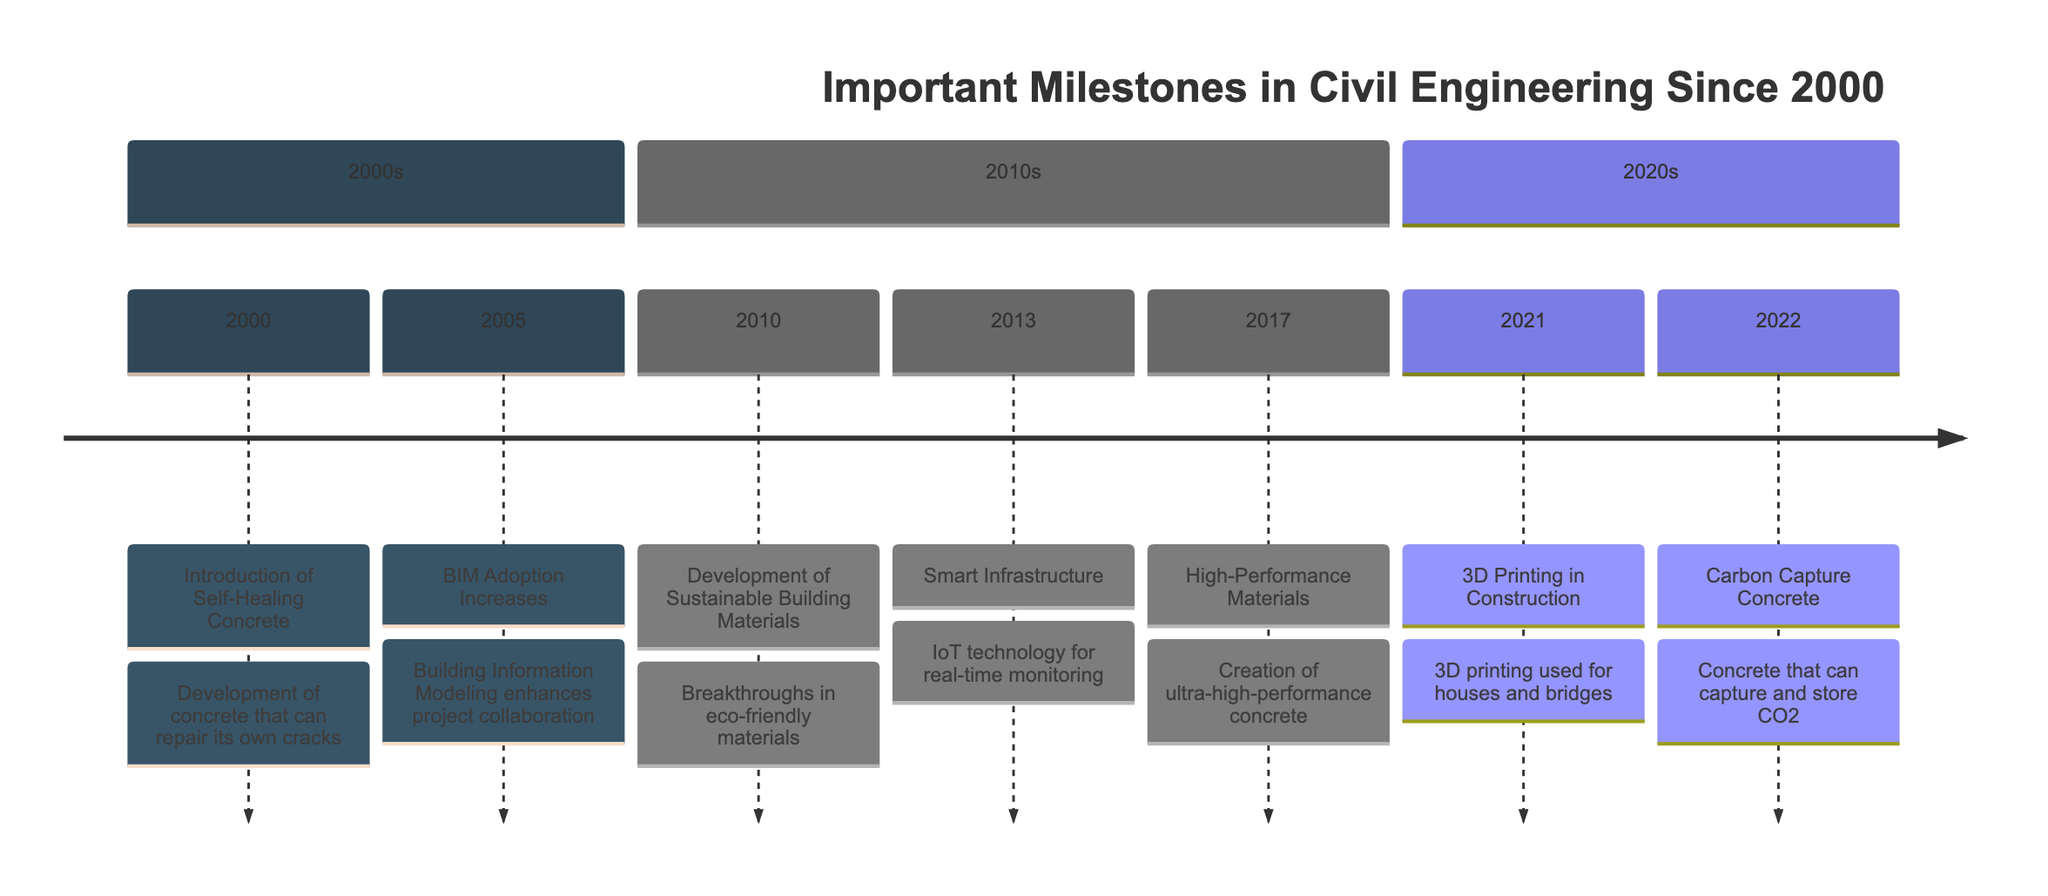What is the first milestone listed in the timeline? The first event in the timeline is from the year 2000, which is the introduction of Self-Healing Concrete. This is the earliest year mentioned and is clearly marked at the beginning of the timeline.
Answer: Introduction of Self-Healing Concrete How many milestones are listed in the timeline? By counting each event in the timeline, there are a total of 7 milestones recorded from 2000 to 2022. Each event is marked as a separate node on the timeline.
Answer: 7 What year did BIM Adoption Increase? Looking at the timeline, BIM Adoption Increases is recorded in the year 2005, which is the specific point in time noted for this event.
Answer: 2005 What is the last milestone year mentioned in the timeline? The last event in the timeline occurs in 2022, which is the final year stated for any milestone, marking the most recent development in the timeline.
Answer: 2022 Which breakthrough involved the use of IoT technology? The event titled Smart Infrastructure, which occurred in 2013, specifically mentions the implementation of IoT technology for monitoring infrastructure, linking the technology directly to the breakthrough.
Answer: Smart Infrastructure Which event introduced carbon capture concrete? The event for carbon capture concrete is recorded in the year 2022, making it clear that this development came at that specific point in time on the timeline.
Answer: Carbon Capture Concrete In which decade did the development of sustainable building materials occur? The development of sustainable building materials occurred in 2010, which falls under the 2010s decade as indicated by the organized sections of the timeline.
Answer: 2010s What common theme is evident in the 2020s milestones? The milestones of the 2020s focus on technological advancements aimed at reducing environmental impact and improving construction efficiency, as seen in both the 3D printing and carbon capture events.
Answer: Environmental sustainability 